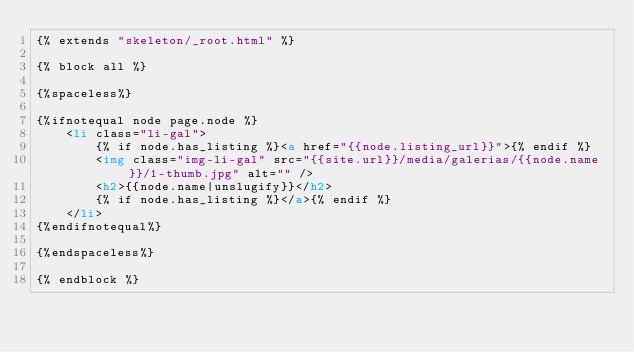<code> <loc_0><loc_0><loc_500><loc_500><_HTML_>{% extends "skeleton/_root.html" %}

{% block all %}

{%spaceless%}

{%ifnotequal node page.node %}
    <li class="li-gal">
        {% if node.has_listing %}<a href="{{node.listing_url}}">{% endif %}
        <img class="img-li-gal" src="{{site.url}}/media/galerias/{{node.name}}/1-thumb.jpg" alt="" />
        <h2>{{node.name|unslugify}}</h2>
        {% if node.has_listing %}</a>{% endif %}
    </li>
{%endifnotequal%}

{%endspaceless%}

{% endblock %}
</code> 